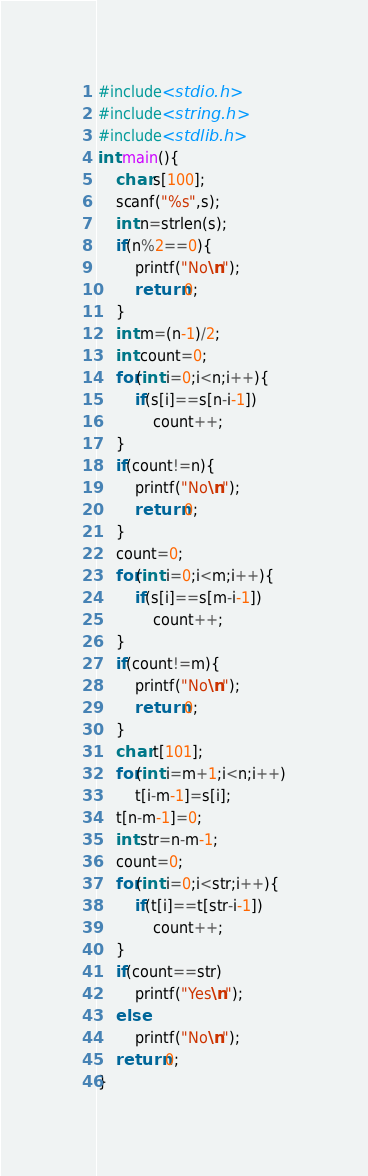Convert code to text. <code><loc_0><loc_0><loc_500><loc_500><_C_>#include<stdio.h>
#include<string.h>
#include<stdlib.h>
int main(){
    char s[100];
    scanf("%s",s);
    int n=strlen(s);
    if(n%2==0){
        printf("No\n");
        return 0;
    }
    int m=(n-1)/2;
    int count=0;
    for(int i=0;i<n;i++){
        if(s[i]==s[n-i-1])
            count++;
    }
    if(count!=n){
        printf("No\n");
        return 0;
    }
    count=0;
    for(int i=0;i<m;i++){
        if(s[i]==s[m-i-1])
            count++;
    }
    if(count!=m){
        printf("No\n");
        return 0;
    }
    char t[101];
    for(int i=m+1;i<n;i++)
        t[i-m-1]=s[i];
    t[n-m-1]=0;
    int str=n-m-1;
    count=0;
    for(int i=0;i<str;i++){
        if(t[i]==t[str-i-1])
            count++;
    }
    if(count==str)
        printf("Yes\n");
    else
        printf("No\n");
    return 0;
}</code> 